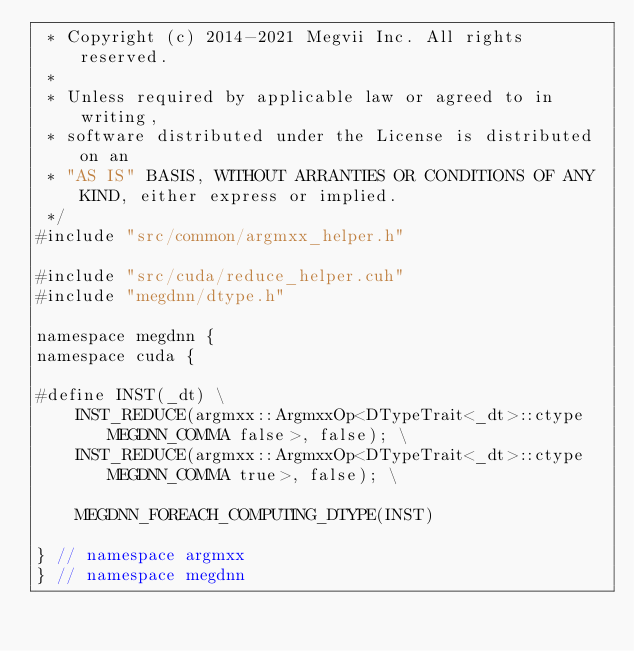Convert code to text. <code><loc_0><loc_0><loc_500><loc_500><_Cuda_> * Copyright (c) 2014-2021 Megvii Inc. All rights reserved.
 *
 * Unless required by applicable law or agreed to in writing,
 * software distributed under the License is distributed on an
 * "AS IS" BASIS, WITHOUT ARRANTIES OR CONDITIONS OF ANY KIND, either express or implied.
 */
#include "src/common/argmxx_helper.h"

#include "src/cuda/reduce_helper.cuh"
#include "megdnn/dtype.h"

namespace megdnn {
namespace cuda {

#define INST(_dt) \
    INST_REDUCE(argmxx::ArgmxxOp<DTypeTrait<_dt>::ctype MEGDNN_COMMA false>, false); \
    INST_REDUCE(argmxx::ArgmxxOp<DTypeTrait<_dt>::ctype MEGDNN_COMMA true>, false); \

    MEGDNN_FOREACH_COMPUTING_DTYPE(INST)

} // namespace argmxx
} // namespace megdnn
</code> 